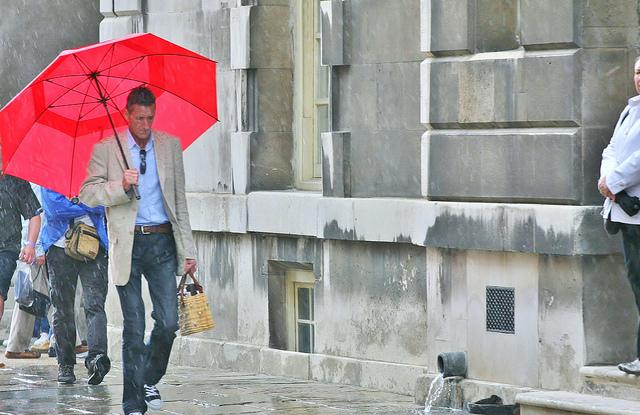Does this man have long hair?
Short answer required. No. What kind of pants is he wearing?
Answer briefly. Jeans. What color is the umbrella?
Keep it brief. Red. Is the person under the umbrella looking for something?
Keep it brief. No. What is the weather?
Concise answer only. Rainy. 